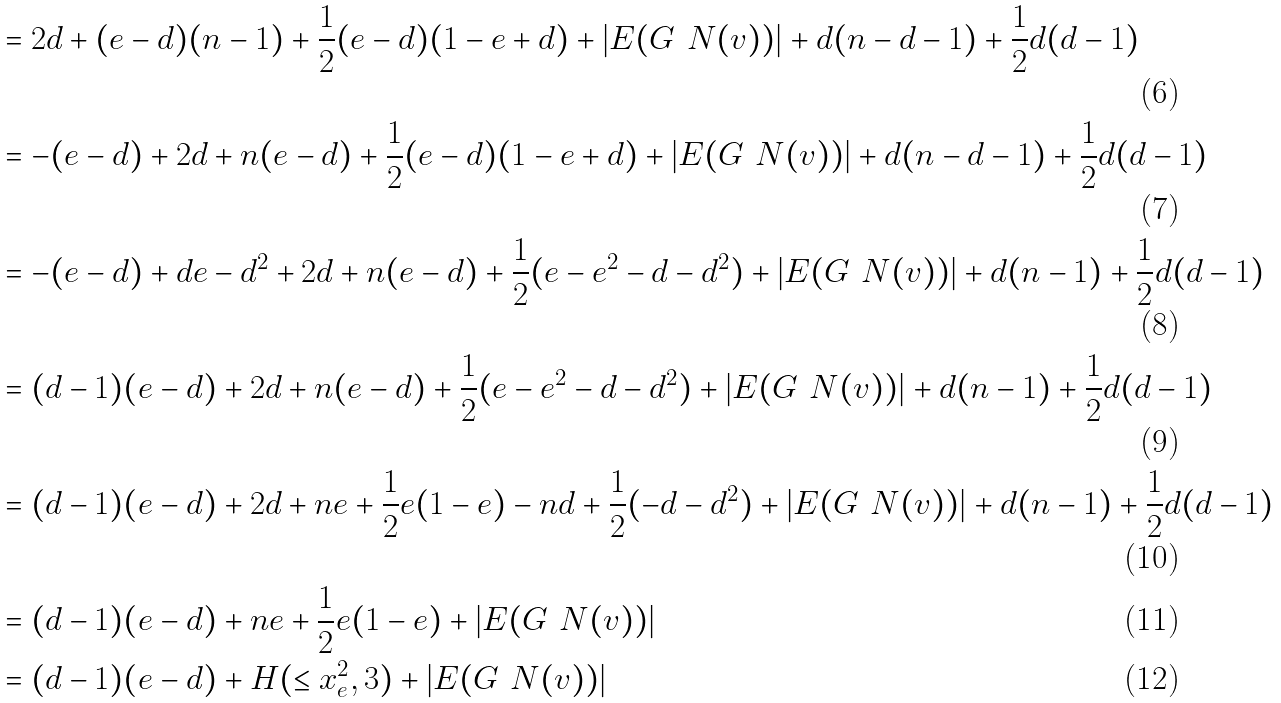Convert formula to latex. <formula><loc_0><loc_0><loc_500><loc_500>& = 2 d + ( e - d ) ( n - 1 ) + \frac { 1 } { 2 } ( e - d ) ( 1 - e + d ) + | E ( G \ N ( v ) ) | + d ( n - d - 1 ) + \frac { 1 } { 2 } d ( d - 1 ) \\ & = - ( e - d ) + 2 d + n ( e - d ) + \frac { 1 } { 2 } ( e - d ) ( 1 - e + d ) + | E ( G \ N ( v ) ) | + d ( n - d - 1 ) + \frac { 1 } { 2 } d ( d - 1 ) \\ & = - ( e - d ) + d e - d ^ { 2 } + 2 d + n ( e - d ) + \frac { 1 } { 2 } ( e - e ^ { 2 } - d - d ^ { 2 } ) + | E ( G \ N ( v ) ) | + d ( n - 1 ) + \frac { 1 } { 2 } d ( d - 1 ) \\ & = ( d - 1 ) ( e - d ) + 2 d + n ( e - d ) + \frac { 1 } { 2 } ( e - e ^ { 2 } - d - d ^ { 2 } ) + | E ( G \ N ( v ) ) | + d ( n - 1 ) + \frac { 1 } { 2 } d ( d - 1 ) \\ & = ( d - 1 ) ( e - d ) + 2 d + n e + \frac { 1 } { 2 } e ( 1 - e ) - n d + \frac { 1 } { 2 } ( - d - d ^ { 2 } ) + | E ( G \ N ( v ) ) | + d ( n - 1 ) + \frac { 1 } { 2 } d ( d - 1 ) \\ & = ( d - 1 ) ( e - d ) + n e + \frac { 1 } { 2 } e ( 1 - e ) + | E ( G \ N ( v ) ) | \\ & = ( d - 1 ) ( e - d ) + H ( \leq x _ { e } ^ { 2 } , 3 ) + | E ( G \ N ( v ) ) |</formula> 